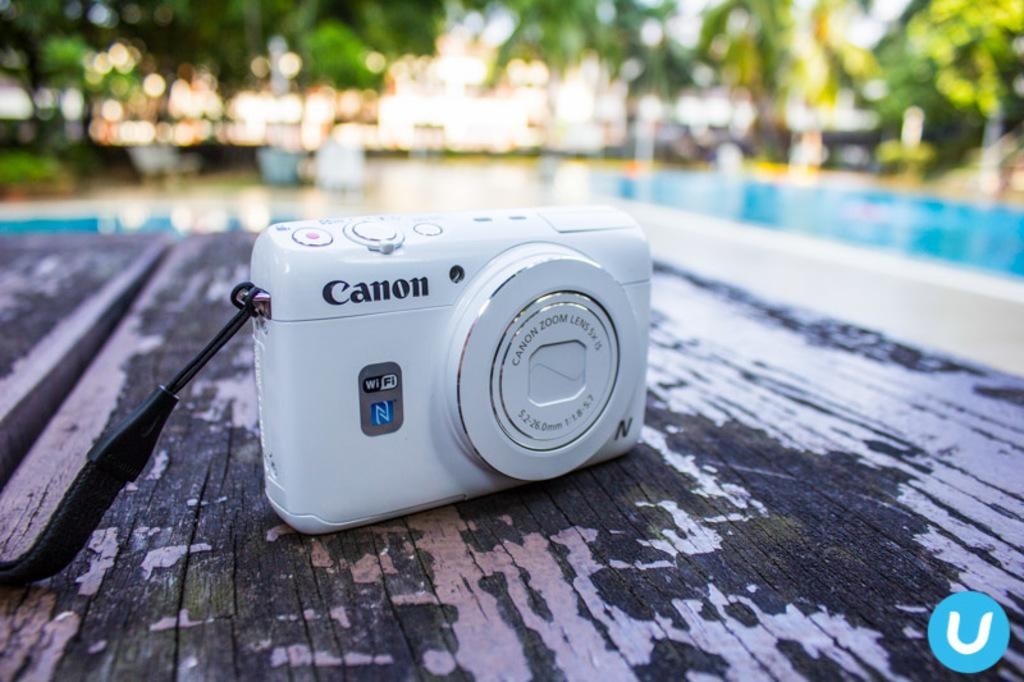What type of camera is in the image? There is a small Canon camera in the image. Where is the camera placed? The camera is placed on a wooden table top. What can be seen in the background of the image? There is a small swimming pool and trees visible in the background. How is the background of the image depicted? The background has a blurred appearance. How does the goose contribute to the comfort of the camera in the image? There is no goose present in the image, so it cannot contribute to the comfort of the camera. 